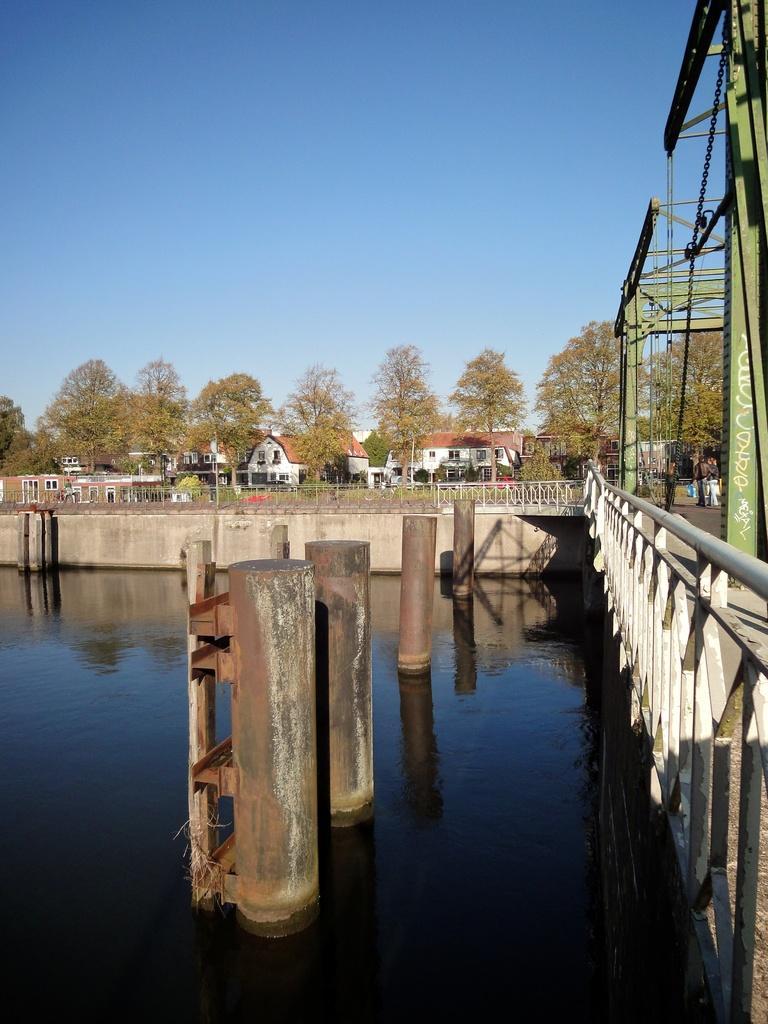Describe this image in one or two sentences. In this picture there is a bridge with metal rods and chains in the right side. There is water with metal rods in the foreground. There are houses and trees in the background and the sky is at the top. 